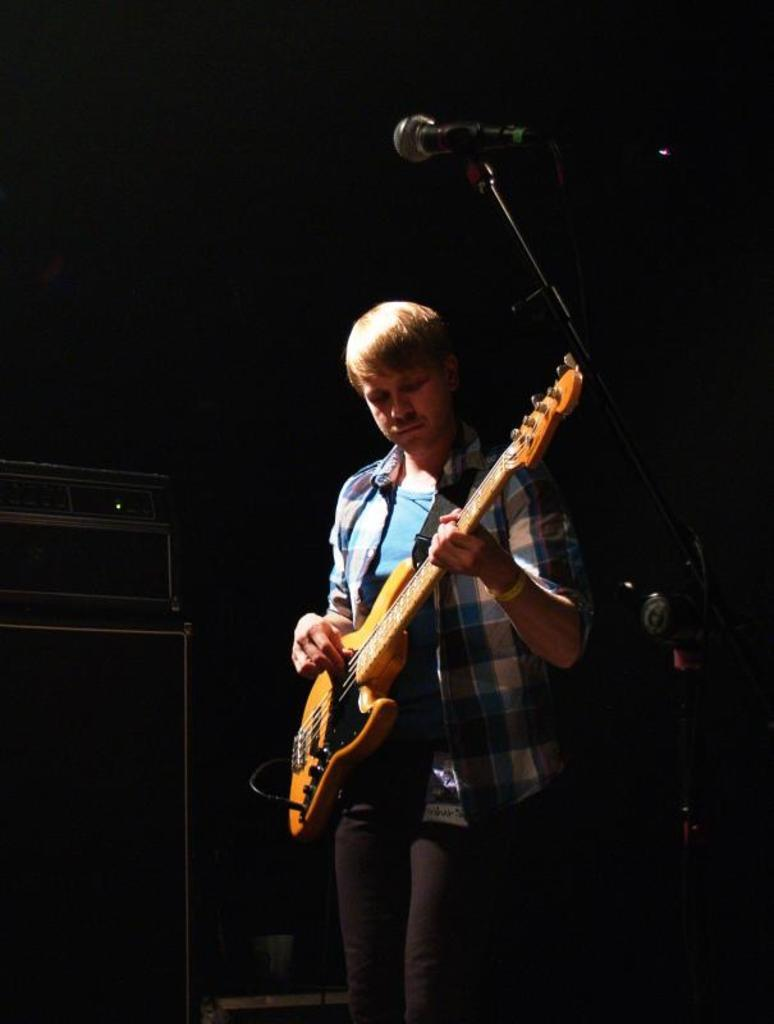What is the main subject of the image? The main subject of the image is a man. What is the man doing in the image? The man is standing in the image. What object is the man holding in the image? The man is holding a guitar in his hands. What type of club does the man use to play the guitar in the image? The image does not show the man using a club to play the guitar; he is simply holding the guitar in his hands. 